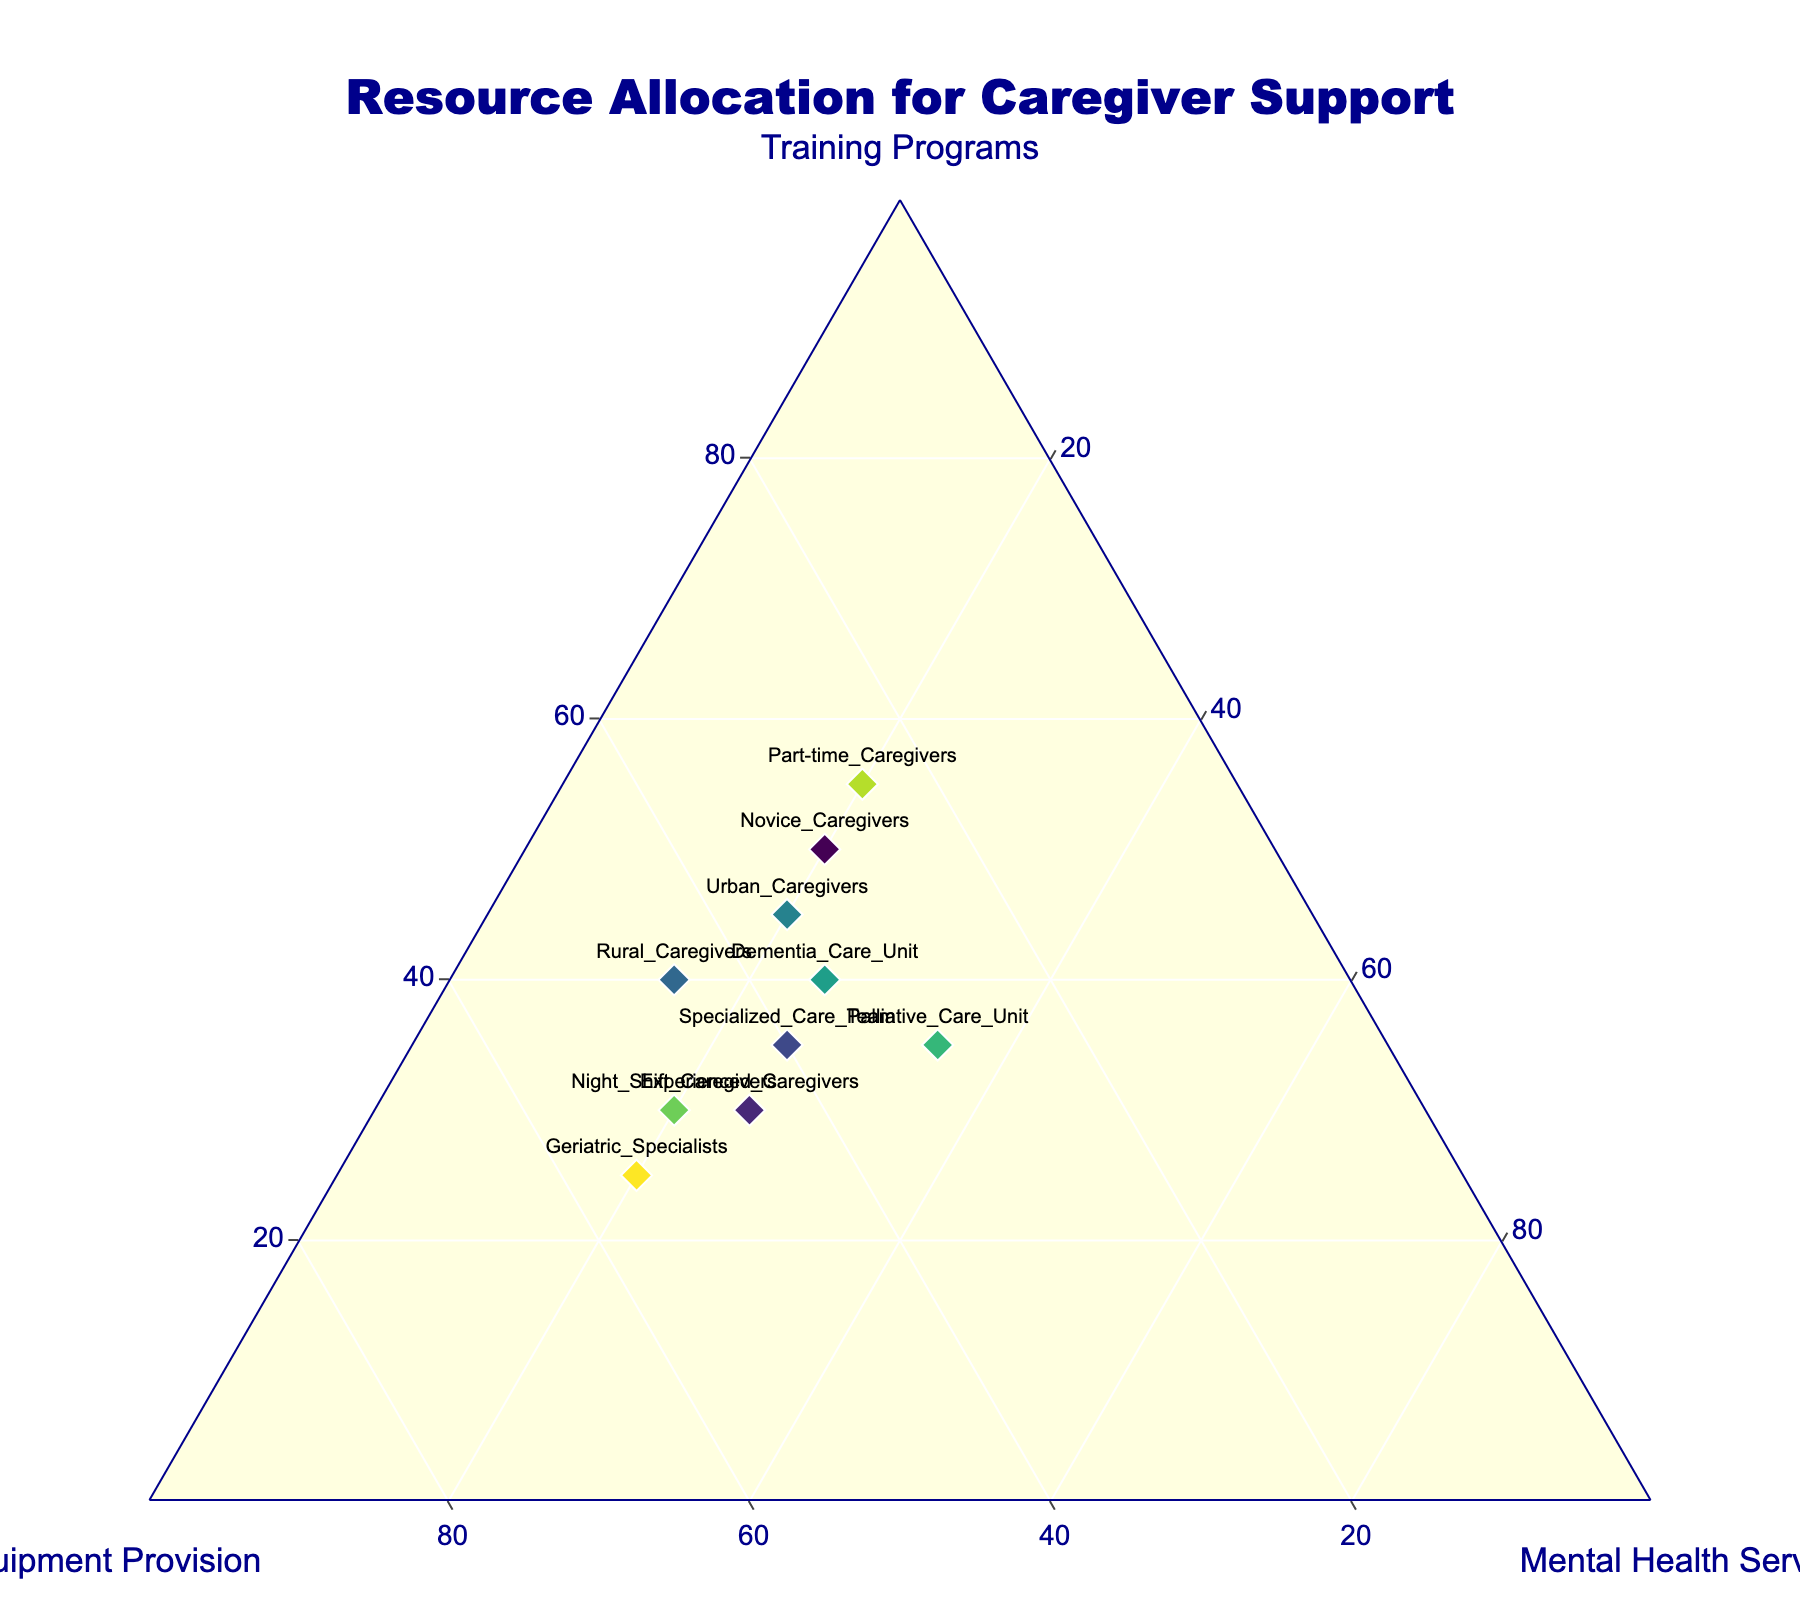What's the title of the figure? The title of the figure should be in a prominent place, usually at the top. In this figure, the title is positioned at the top center. It reads "Resource Allocation for Caregiver Support".
Answer: Resource Allocation for Caregiver Support How many caregiver groups are depicted in the figure? To find the number of caregiver groups, you count the number of labeled points on the ternary plot. Each label corresponds to a different group. There are 10 labels present.
Answer: 10 Which caregiver group has the highest proportion of equipment provision? Identify the point on the ternary plot closest to the "Equipment Provision" axis vertex, indicating the highest proportion. "Geriatric Specialists" is the closest to this vertex.
Answer: Geriatric Specialists Compare the resource allocation between "Part-time Caregivers" and "Urban Caregivers." Which has a larger focus on training programs? Locate both "Part-time Caregivers" and "Urban Caregivers" on the plot. The point closer to the "Training Programs" axis vertex indicates a larger focus. "Part-time Caregivers" is closer to this vertex.
Answer: Part-time Caregivers Which caregiver group has an equal proportion of training programs and mental health services? Find the data point located along the line equidistant from the "Training Programs" and "Mental Health Services" vertices. "Palliative Care Unit" lies on this line, indicating equal focus.
Answer: Palliative Care Unit What proportion of resources is allocated to mental health services for "Rural Caregivers"? Locate the "Rural Caregivers" point on the ternary plot. From the plot, this group shows a lower proportion of mental health services compared to other resources. The exact percentage shown is 15%.
Answer: 15% Rank the groups "Novice Caregivers," "Experienced Caregivers," and "Night Shift Caregivers" based on their proportion of equipment provision, from highest to lowest. Check the plot to compare each group's proximity to the "Equipment Provision" vertex. The ranking in descending order is: "Night Shift Caregivers," "Experienced Caregivers," and "Novice Caregivers."
Answer: Night Shift Caregivers, Experienced Caregivers, Novice Caregivers Which group shows the most balanced allocation of resources among the three categories? The most balanced allocation will typically be a point near the center of the ternary plot, indicating similar proportions for all resources. "Specialized Care Team" appears most central.
Answer: Specialized Care Team 